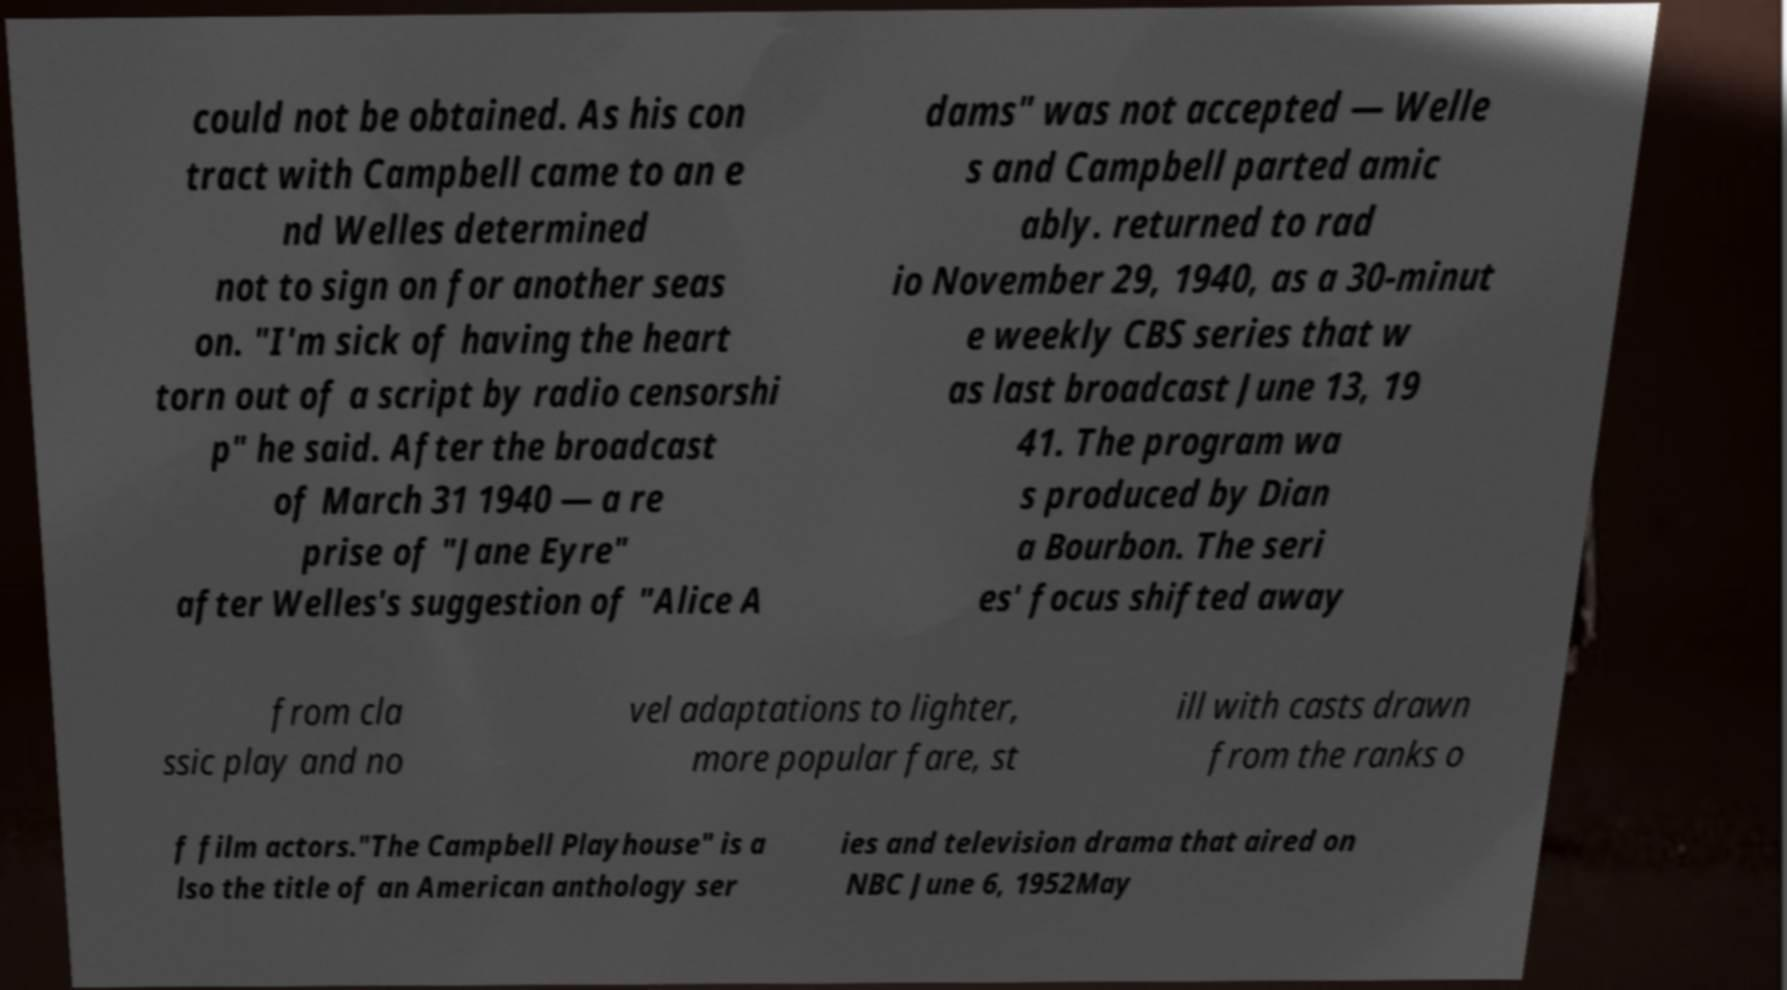Can you accurately transcribe the text from the provided image for me? could not be obtained. As his con tract with Campbell came to an e nd Welles determined not to sign on for another seas on. "I'm sick of having the heart torn out of a script by radio censorshi p" he said. After the broadcast of March 31 1940 — a re prise of "Jane Eyre" after Welles's suggestion of "Alice A dams" was not accepted — Welle s and Campbell parted amic ably. returned to rad io November 29, 1940, as a 30-minut e weekly CBS series that w as last broadcast June 13, 19 41. The program wa s produced by Dian a Bourbon. The seri es' focus shifted away from cla ssic play and no vel adaptations to lighter, more popular fare, st ill with casts drawn from the ranks o f film actors."The Campbell Playhouse" is a lso the title of an American anthology ser ies and television drama that aired on NBC June 6, 1952May 